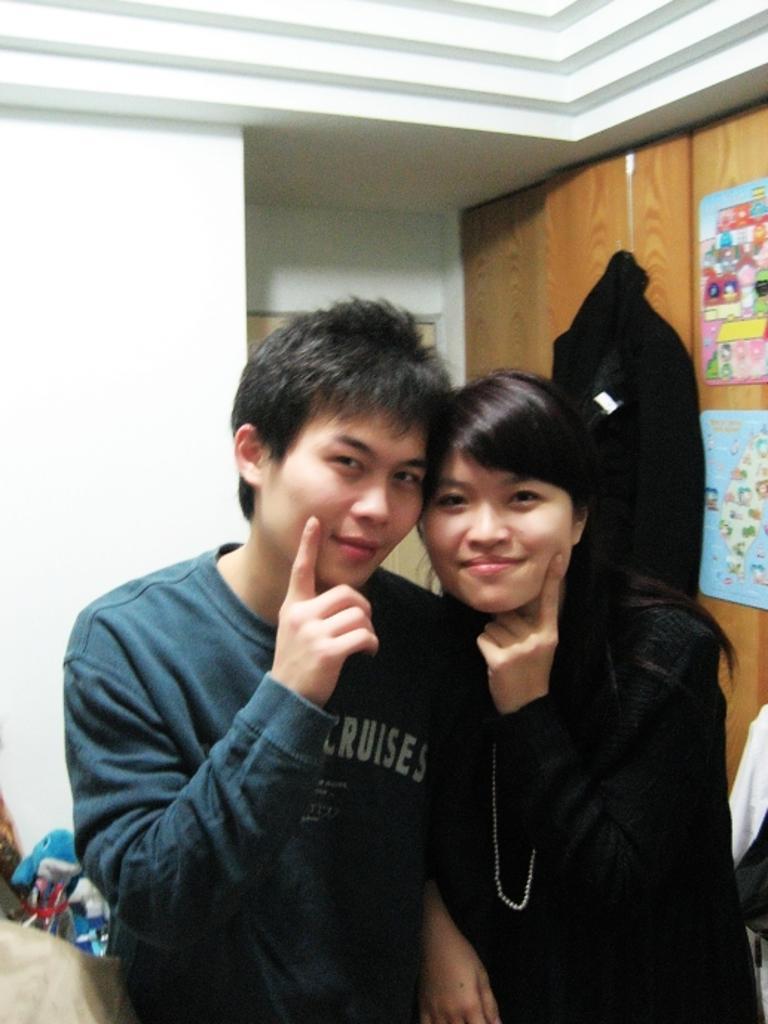Can you describe this image briefly? In this image there are two persons standing and smiling, and there are papers stick to the cupboard,toys, and there are some objects and a wall. 